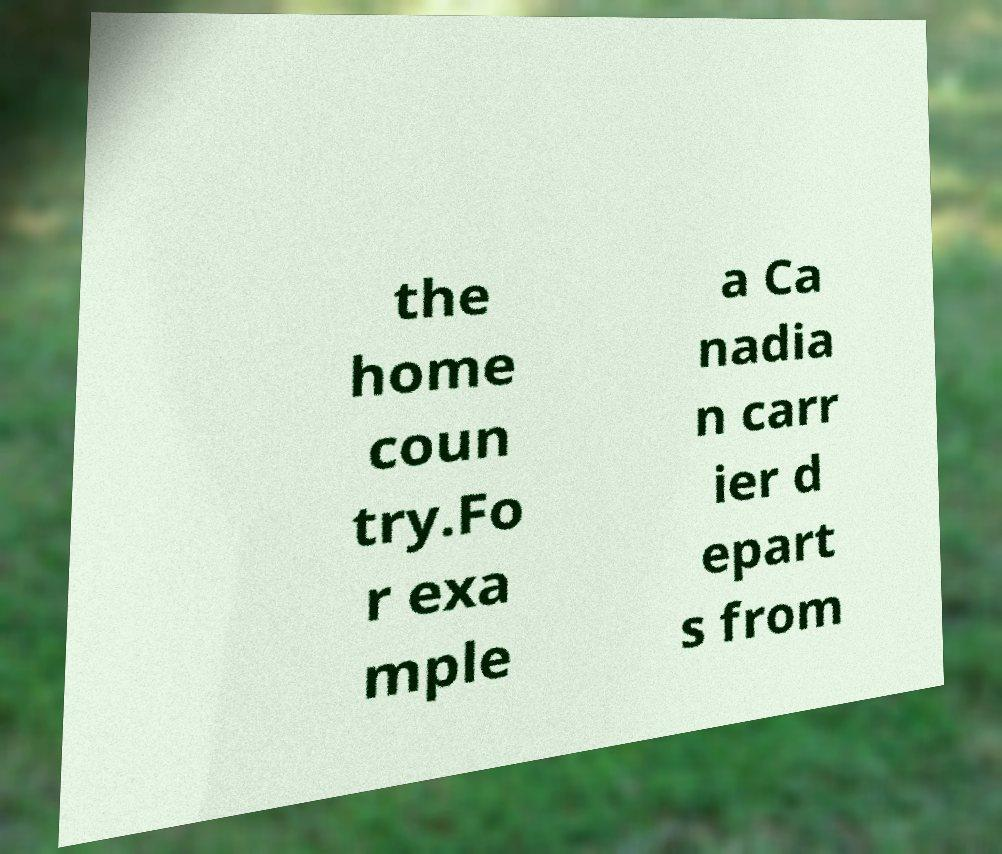Please read and relay the text visible in this image. What does it say? the home coun try.Fo r exa mple a Ca nadia n carr ier d epart s from 